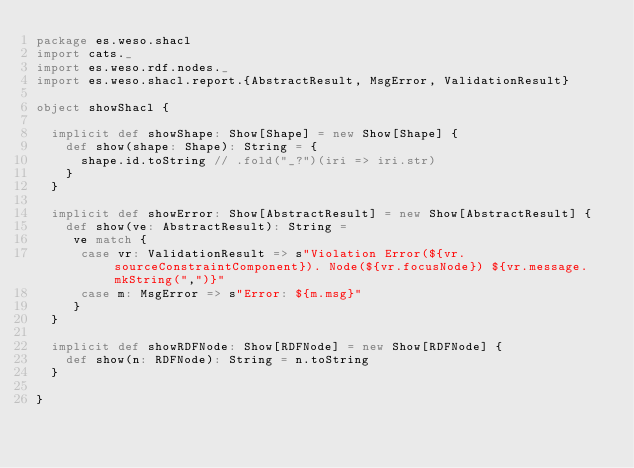<code> <loc_0><loc_0><loc_500><loc_500><_Scala_>package es.weso.shacl
import cats._
import es.weso.rdf.nodes._
import es.weso.shacl.report.{AbstractResult, MsgError, ValidationResult}

object showShacl {

  implicit def showShape: Show[Shape] = new Show[Shape] {
    def show(shape: Shape): String = {
      shape.id.toString // .fold("_?")(iri => iri.str)
    }
  }

  implicit def showError: Show[AbstractResult] = new Show[AbstractResult] {
    def show(ve: AbstractResult): String =
     ve match {
      case vr: ValidationResult => s"Violation Error(${vr.sourceConstraintComponent}). Node(${vr.focusNode}) ${vr.message.mkString(",")}"
      case m: MsgError => s"Error: ${m.msg}"
     }
  }

  implicit def showRDFNode: Show[RDFNode] = new Show[RDFNode] {
    def show(n: RDFNode): String = n.toString
  }

}
</code> 